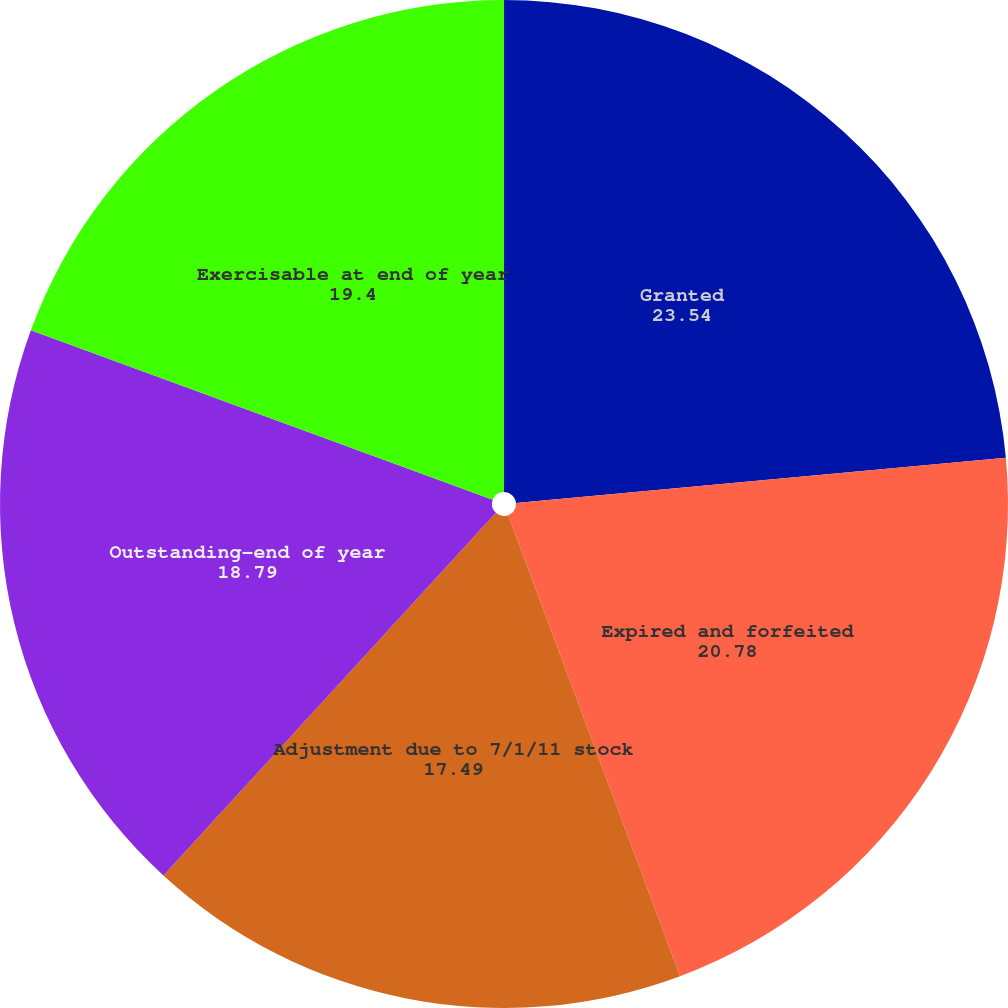Convert chart to OTSL. <chart><loc_0><loc_0><loc_500><loc_500><pie_chart><fcel>Granted<fcel>Expired and forfeited<fcel>Adjustment due to 7/1/11 stock<fcel>Outstanding-end of year<fcel>Exercisable at end of year<nl><fcel>23.54%<fcel>20.78%<fcel>17.49%<fcel>18.79%<fcel>19.4%<nl></chart> 